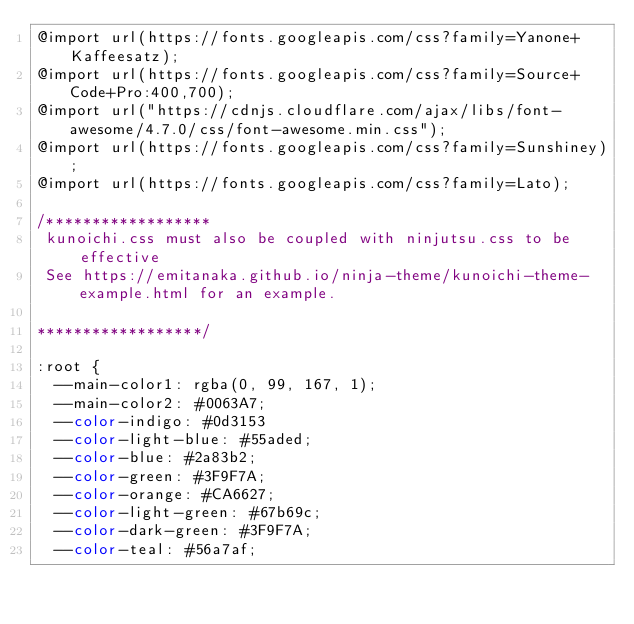<code> <loc_0><loc_0><loc_500><loc_500><_CSS_>@import url(https://fonts.googleapis.com/css?family=Yanone+Kaffeesatz);
@import url(https://fonts.googleapis.com/css?family=Source+Code+Pro:400,700);
@import url("https://cdnjs.cloudflare.com/ajax/libs/font-awesome/4.7.0/css/font-awesome.min.css");
@import url(https://fonts.googleapis.com/css?family=Sunshiney);
@import url(https://fonts.googleapis.com/css?family=Lato);

/******************
 kunoichi.css must also be coupled with ninjutsu.css to be effective
 See https://emitanaka.github.io/ninja-theme/kunoichi-theme-example.html for an example.

******************/

:root {
  --main-color1: rgba(0, 99, 167, 1);
  --main-color2: #0063A7;
  --color-indigo: #0d3153
  --color-light-blue: #55aded;
  --color-blue: #2a83b2;
  --color-green: #3F9F7A;
  --color-orange: #CA6627;
  --color-light-green: #67b69c;
  --color-dark-green: #3F9F7A;
  --color-teal: #56a7af; </code> 